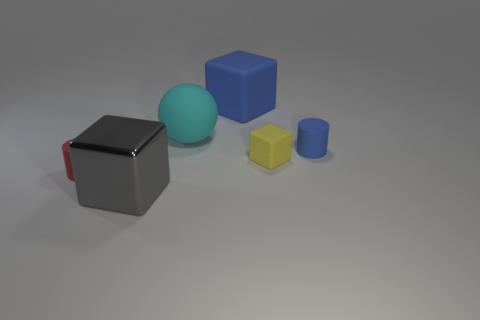Add 3 large blue cylinders. How many objects exist? 9 Subtract all balls. How many objects are left? 5 Subtract 0 green blocks. How many objects are left? 6 Subtract all large blue blocks. Subtract all big green rubber blocks. How many objects are left? 5 Add 5 cyan objects. How many cyan objects are left? 6 Add 4 red cylinders. How many red cylinders exist? 5 